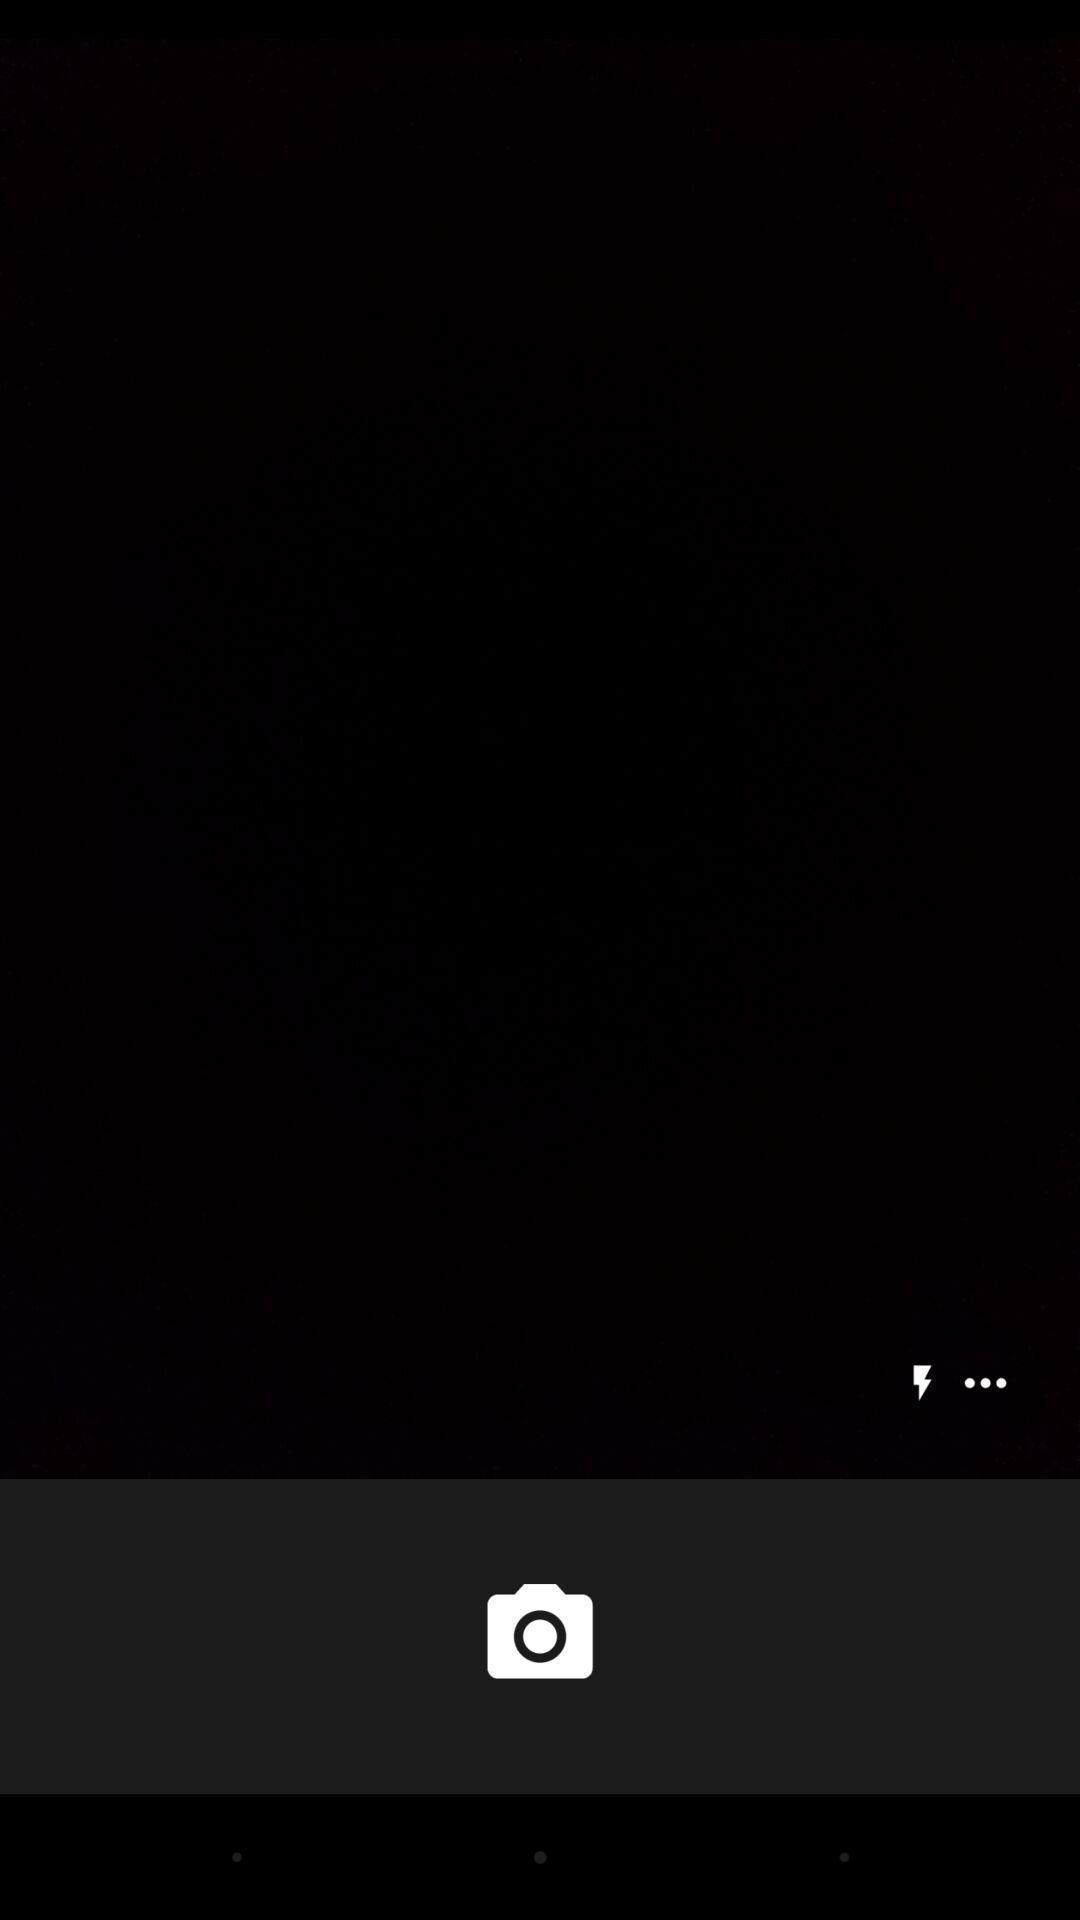Give me a narrative description of this picture. Screen shows a blank camera page. 